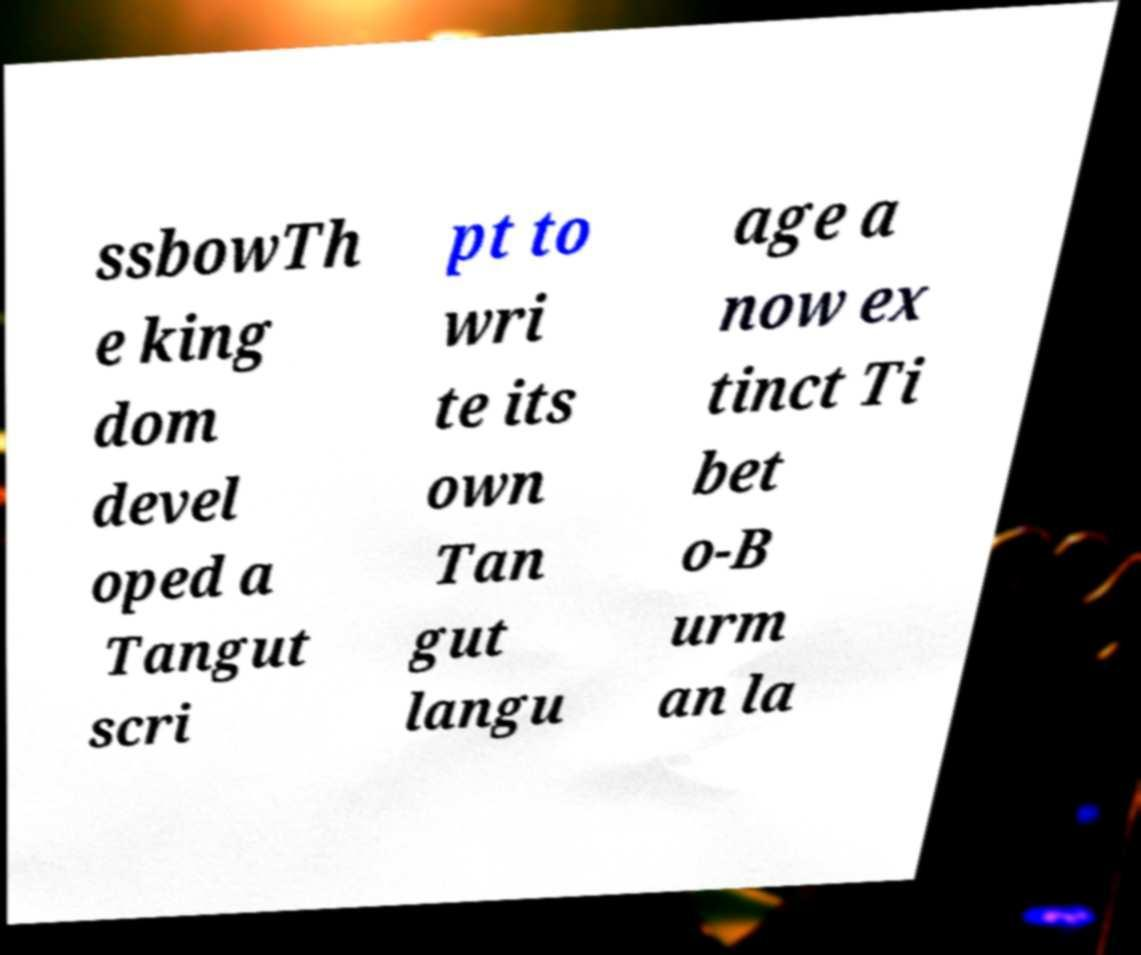Could you extract and type out the text from this image? ssbowTh e king dom devel oped a Tangut scri pt to wri te its own Tan gut langu age a now ex tinct Ti bet o-B urm an la 